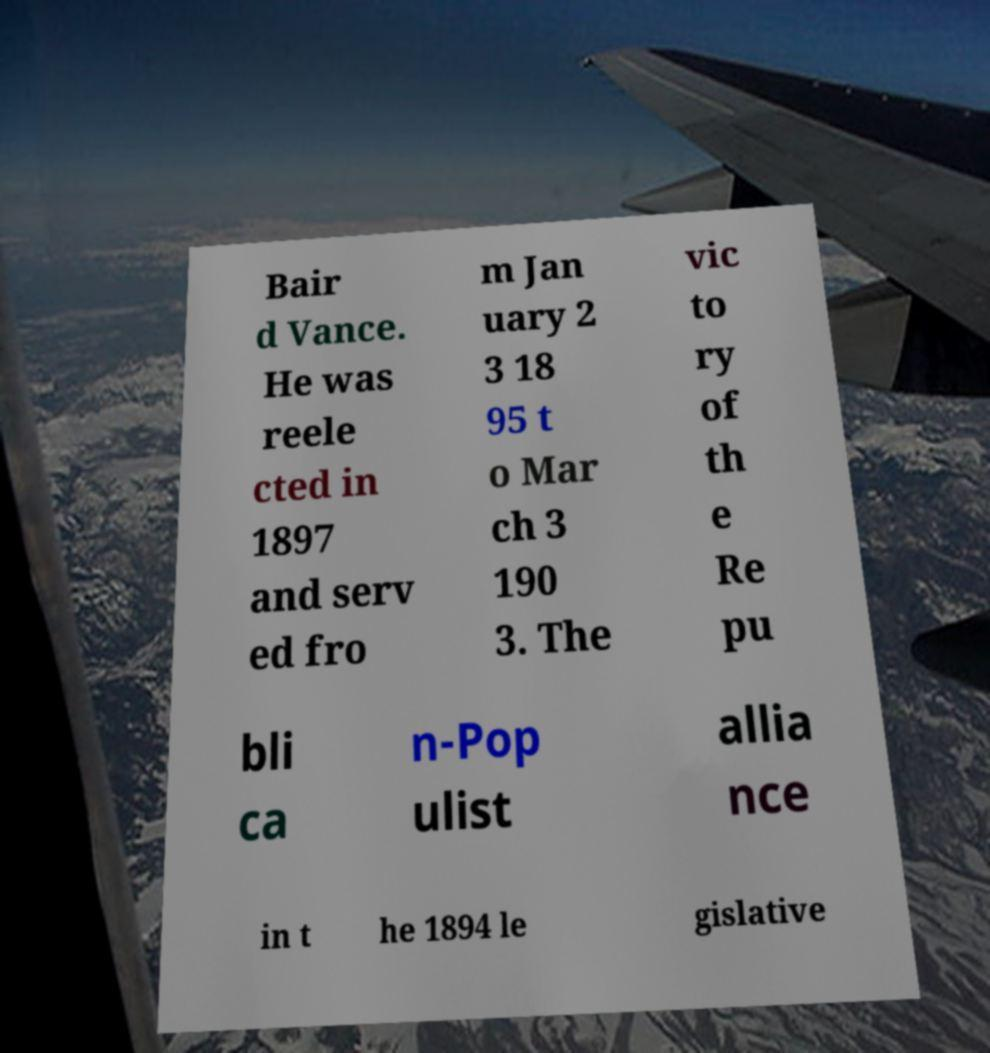Please identify and transcribe the text found in this image. Bair d Vance. He was reele cted in 1897 and serv ed fro m Jan uary 2 3 18 95 t o Mar ch 3 190 3. The vic to ry of th e Re pu bli ca n-Pop ulist allia nce in t he 1894 le gislative 